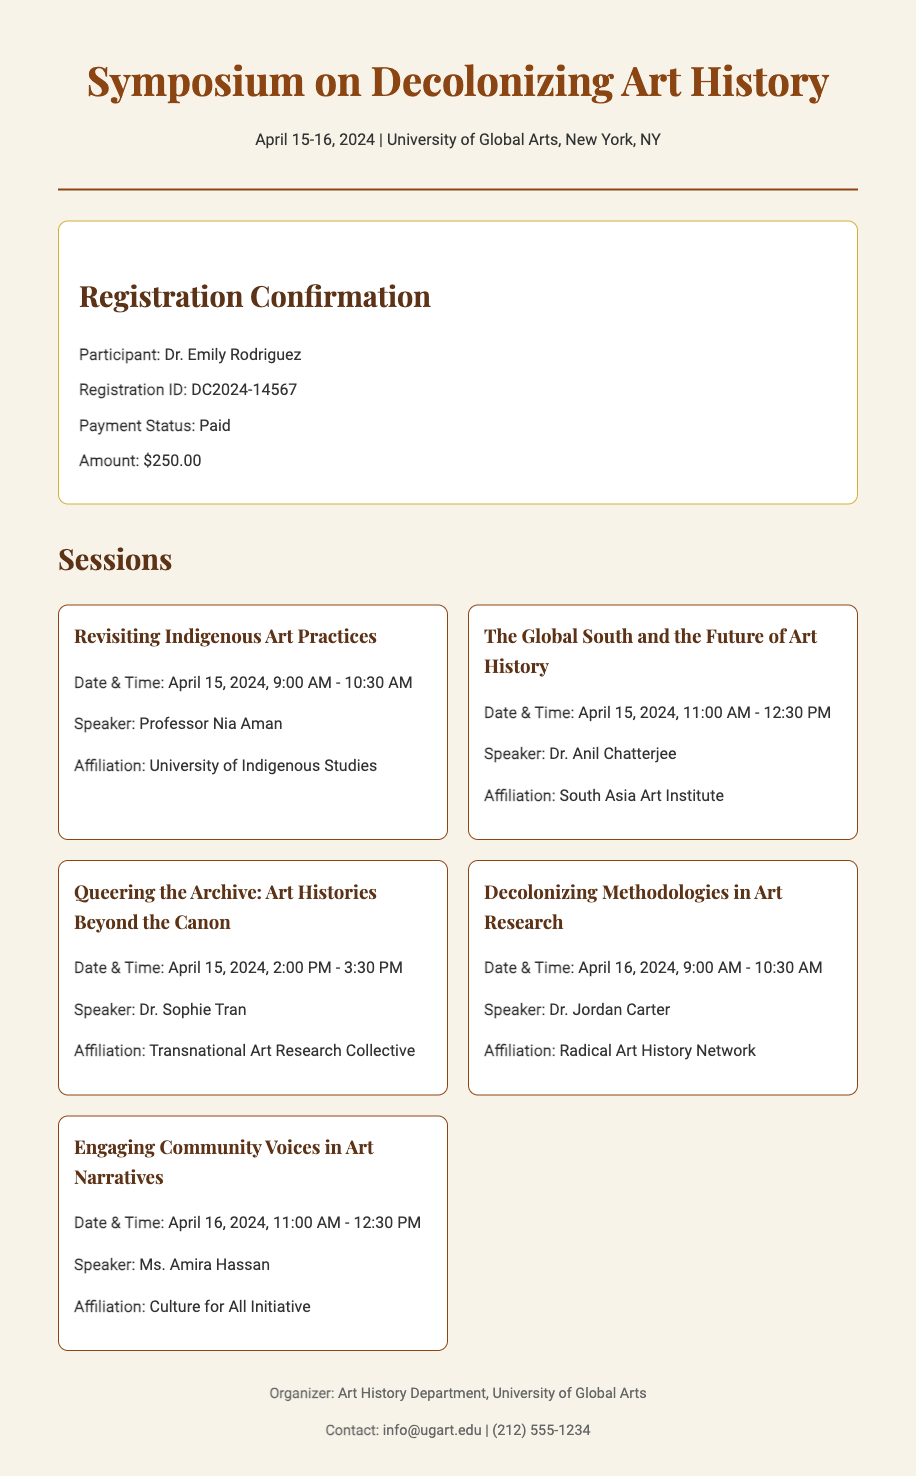What is the registration ID? The registration ID is found in the confirmation details section of the document.
Answer: DC2024-14567 Who is the speaker for the session "Engaging Community Voices in Art Narratives"? This information is located in the session details for "Engaging Community Voices in Art Narratives".
Answer: Ms. Amira Hassan What is the payment status? The payment status is mentioned in the confirmation details of the document.
Answer: Paid How much is the registration fee? The registration fee is specified in the confirmation section alongside the payment status.
Answer: $250.00 What is the date and time for the session "Queering the Archive: Art Histories Beyond the Canon"? This information is included in the session details for "Queering the Archive".
Answer: April 15, 2024, 2:00 PM - 3:30 PM Who is organizing the symposium? The organizing body is stated in the footer section of the document.
Answer: Art History Department, University of Global Arts What is the theme of the first session? The theme can be determined from the title of the first session listed in the document.
Answer: Revisiting Indigenous Art Practices What is the location of the symposium? The location is provided in the header of the document.
Answer: University of Global Arts, New York, NY How many sessions are there in total? This can be calculated by counting the sessions listed in the document.
Answer: Five 